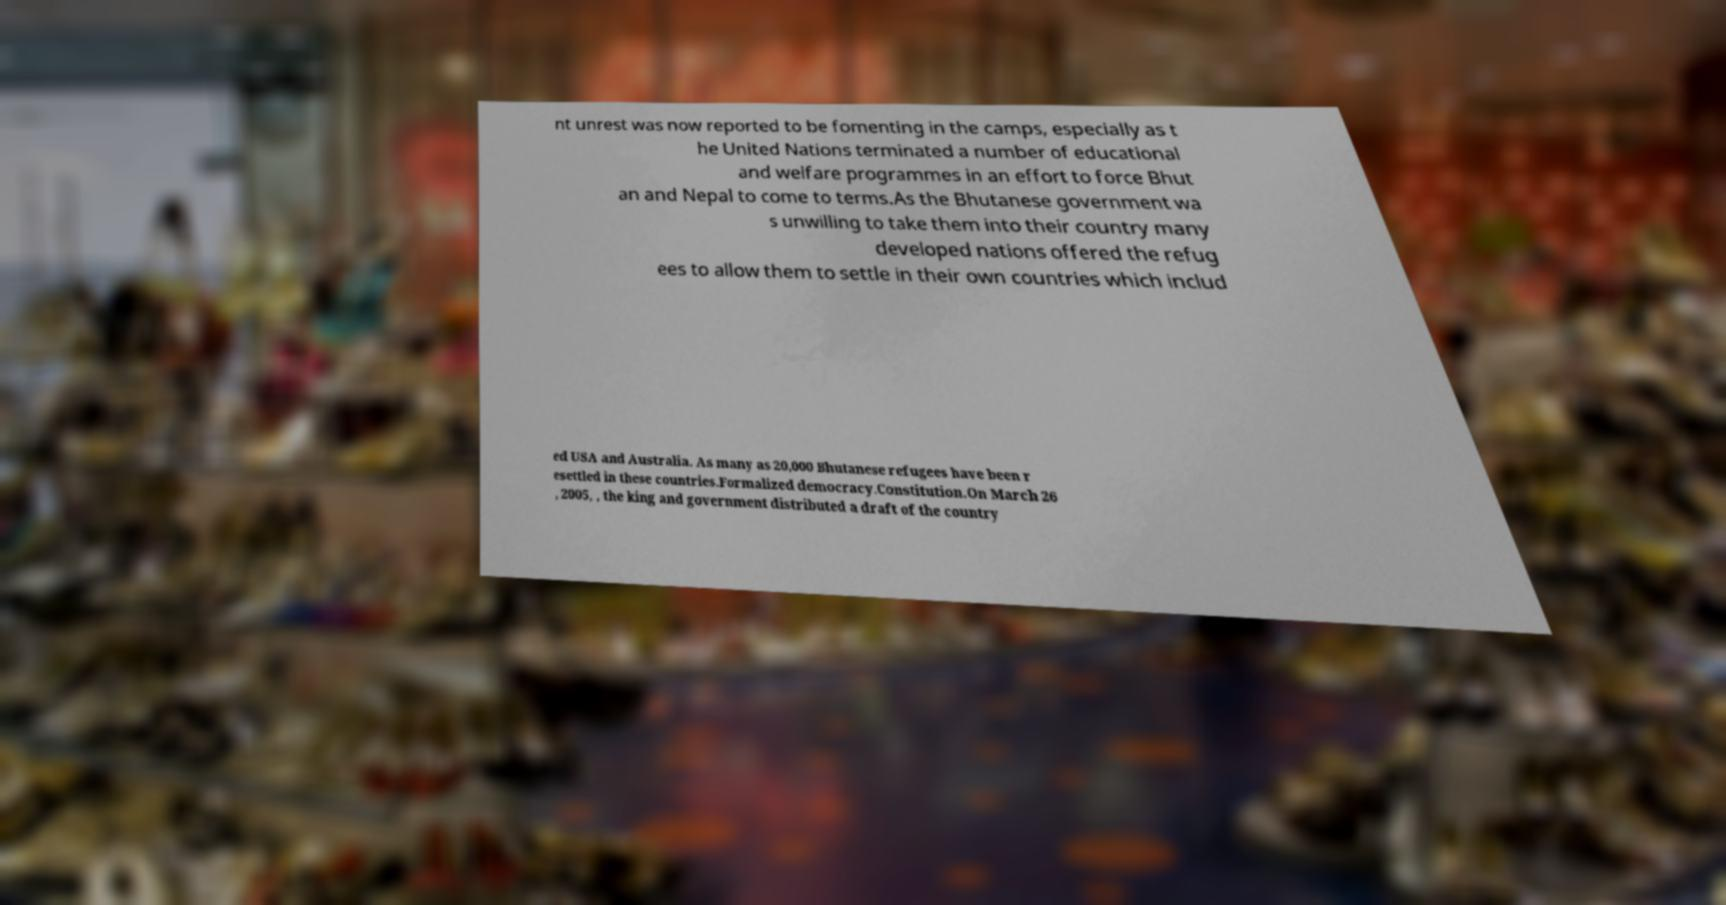Can you read and provide the text displayed in the image?This photo seems to have some interesting text. Can you extract and type it out for me? nt unrest was now reported to be fomenting in the camps, especially as t he United Nations terminated a number of educational and welfare programmes in an effort to force Bhut an and Nepal to come to terms.As the Bhutanese government wa s unwilling to take them into their country many developed nations offered the refug ees to allow them to settle in their own countries which includ ed USA and Australia. As many as 20,000 Bhutanese refugees have been r esettled in these countries.Formalized democracy.Constitution.On March 26 , 2005, , the king and government distributed a draft of the country 